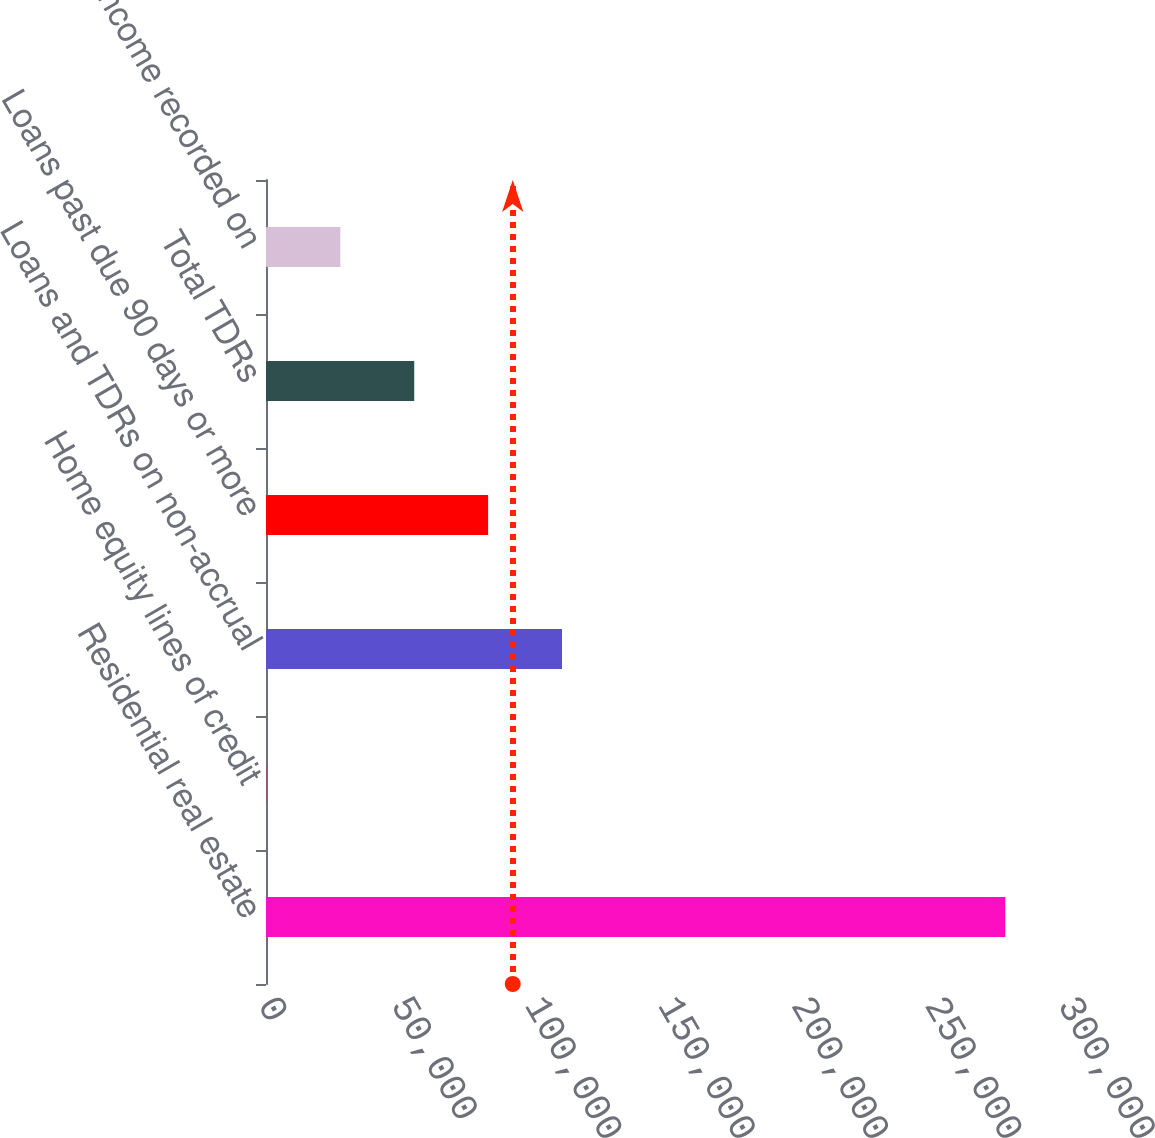Convert chart. <chart><loc_0><loc_0><loc_500><loc_500><bar_chart><fcel>Residential real estate<fcel>Home equity lines of credit<fcel>Loans and TDRs on non-accrual<fcel>Loans past due 90 days or more<fcel>Total TDRs<fcel>Interest income recorded on<nl><fcel>277253<fcel>170<fcel>111003<fcel>83294.9<fcel>55586.6<fcel>27878.3<nl></chart> 